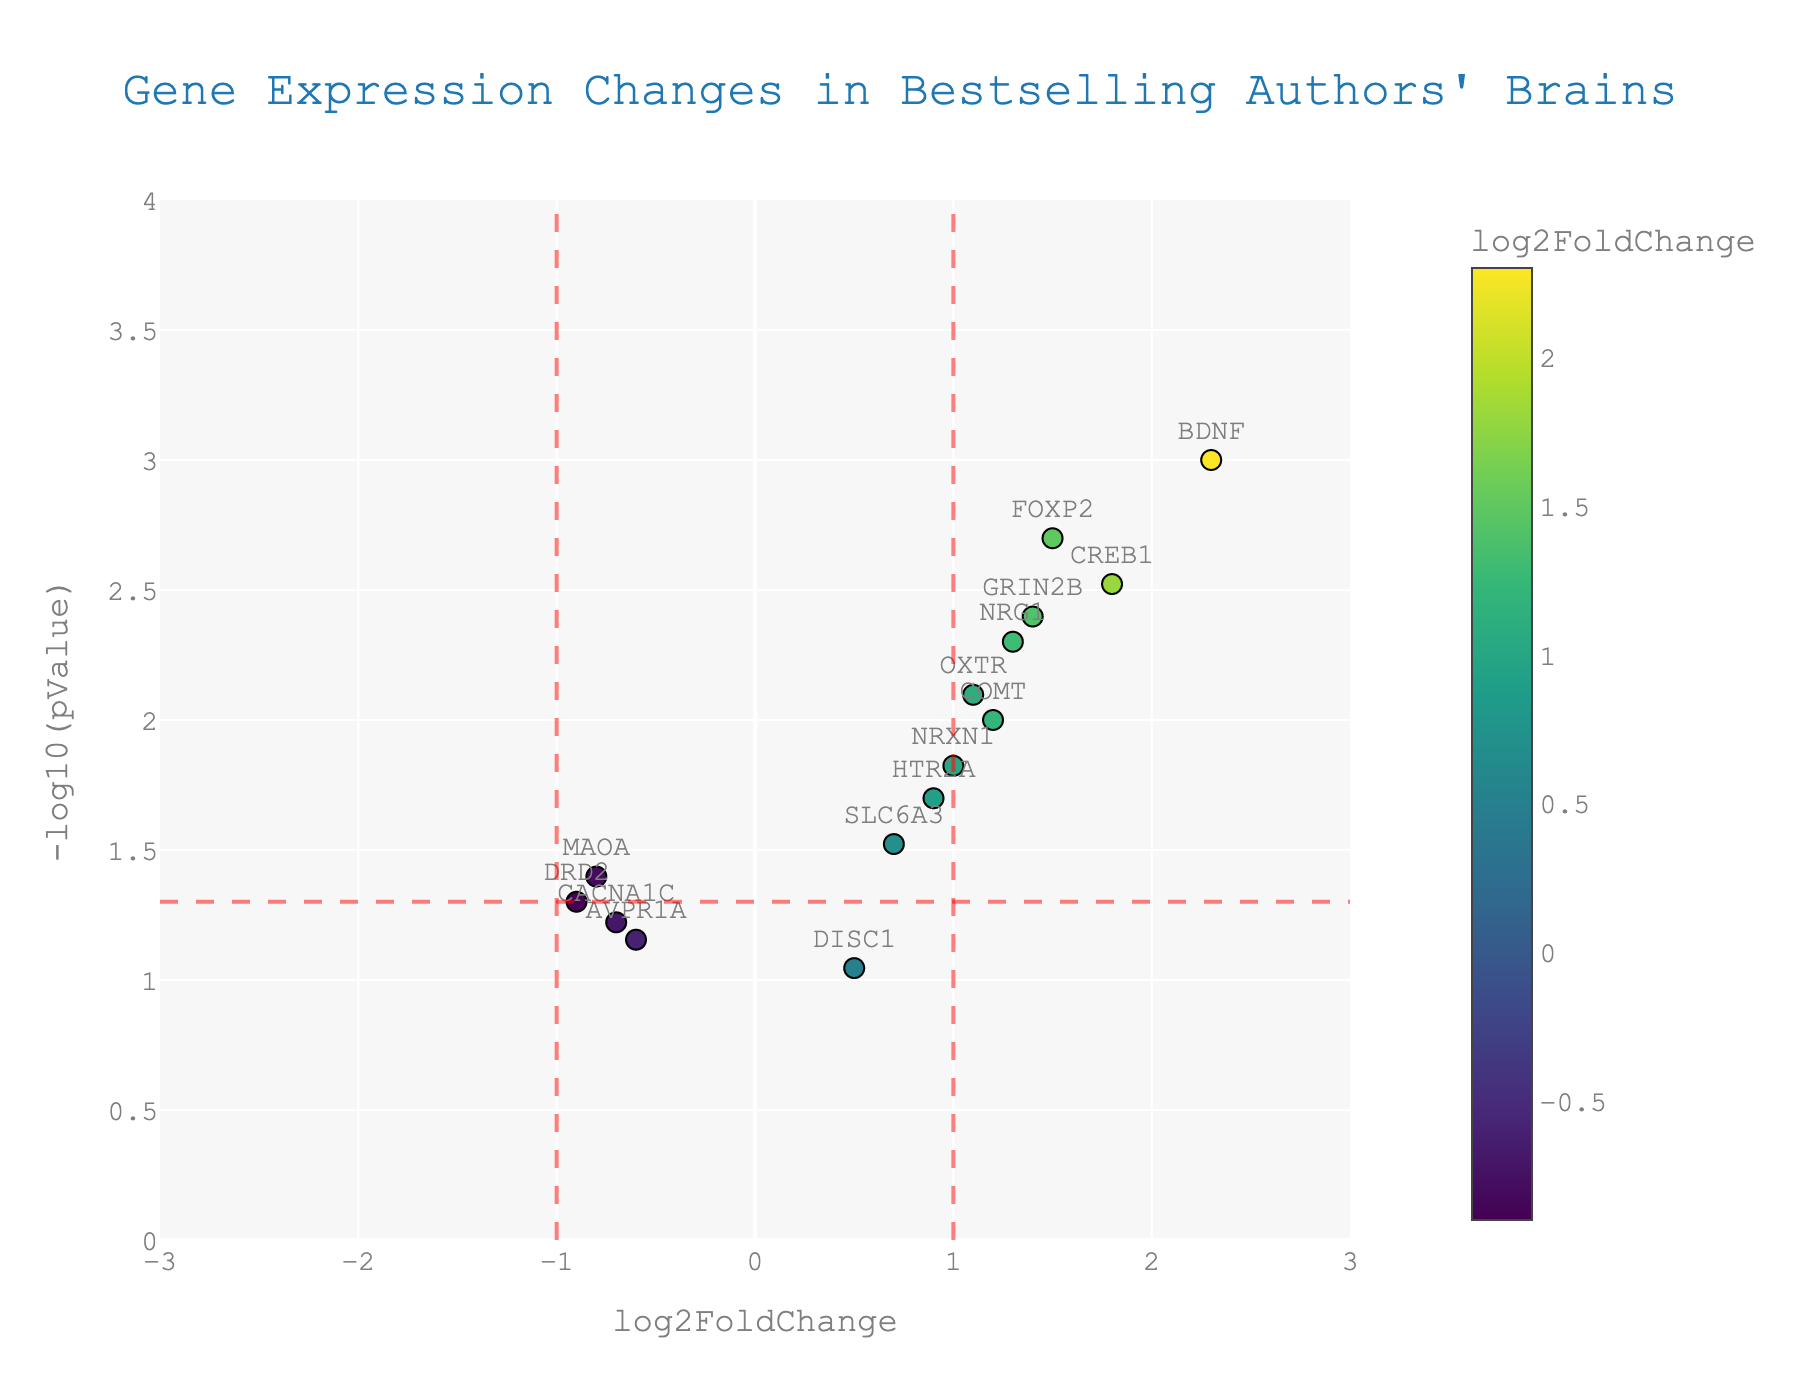What is the title of the figure? The title is displayed at the top center in large, bold font. It reads "Gene Expression Changes in Bestselling Authors' Brains".
Answer: Gene Expression Changes in Bestselling Authors' Brains How is the p-value represented in the y-axis? On the y-axis, p-values are represented as -log10(pValue), meaning that smaller p-values translate to higher values on this axis.
Answer: -log10(pValue) How many genes have a log2FoldChange greater than 1? By looking at the x-axis, we can identify the genes placed on the right side of the vertical red dashed line (x = 1). There are 5 such genes: BDNF, CREB1, FOXP2, NRG1, and GRIN2B.
Answer: 5 Which gene has the highest log2FoldChange? The gene with the highest log2FoldChange is positioned furthest to the right on the x-axis. That gene is BDNF with a log2FoldChange of 2.3.
Answer: BDNF What does the red horizontal dashed line represent? The red horizontal dashed line corresponds to a p-value of 0.05. It is the threshold for statistical significance; points above this line have p-values less than 0.05.
Answer: p-value threshold (0.05) How many points are above the red horizontal dashed line? To determine this, count the points above the y=1.3 line, which equates to a p-value of 0.05. There are 9 points above this line.
Answer: 9 Which gene is closest to the point (1, 3)? By observing the plot, we can see which gene's marker is nearest the coordinates (1, 3) on the plot. The gene GRIN2B is closest to this point.
Answer: GRIN2B How are the colors of the markers determined? The colors of the markers are based on the log2FoldChange values, with the colorscale indicated as 'Viridis' and showing a gradient.
Answer: log2FoldChange values Which genes are downregulated with p-values less than 0.05? Downregulated genes have negative log2FoldChange values and lie above the red horizontal line at y= -log10(0.05). The genes DRD2 and MAOA meet this criterion.
Answer: DRD2 and MAOA What does the size of the markers signify? The size of the markers is consistent across the plot and does not represent any variable in the dataset. Each marker has a size of 10, showing no variation.
Answer: Consistent size (10) 